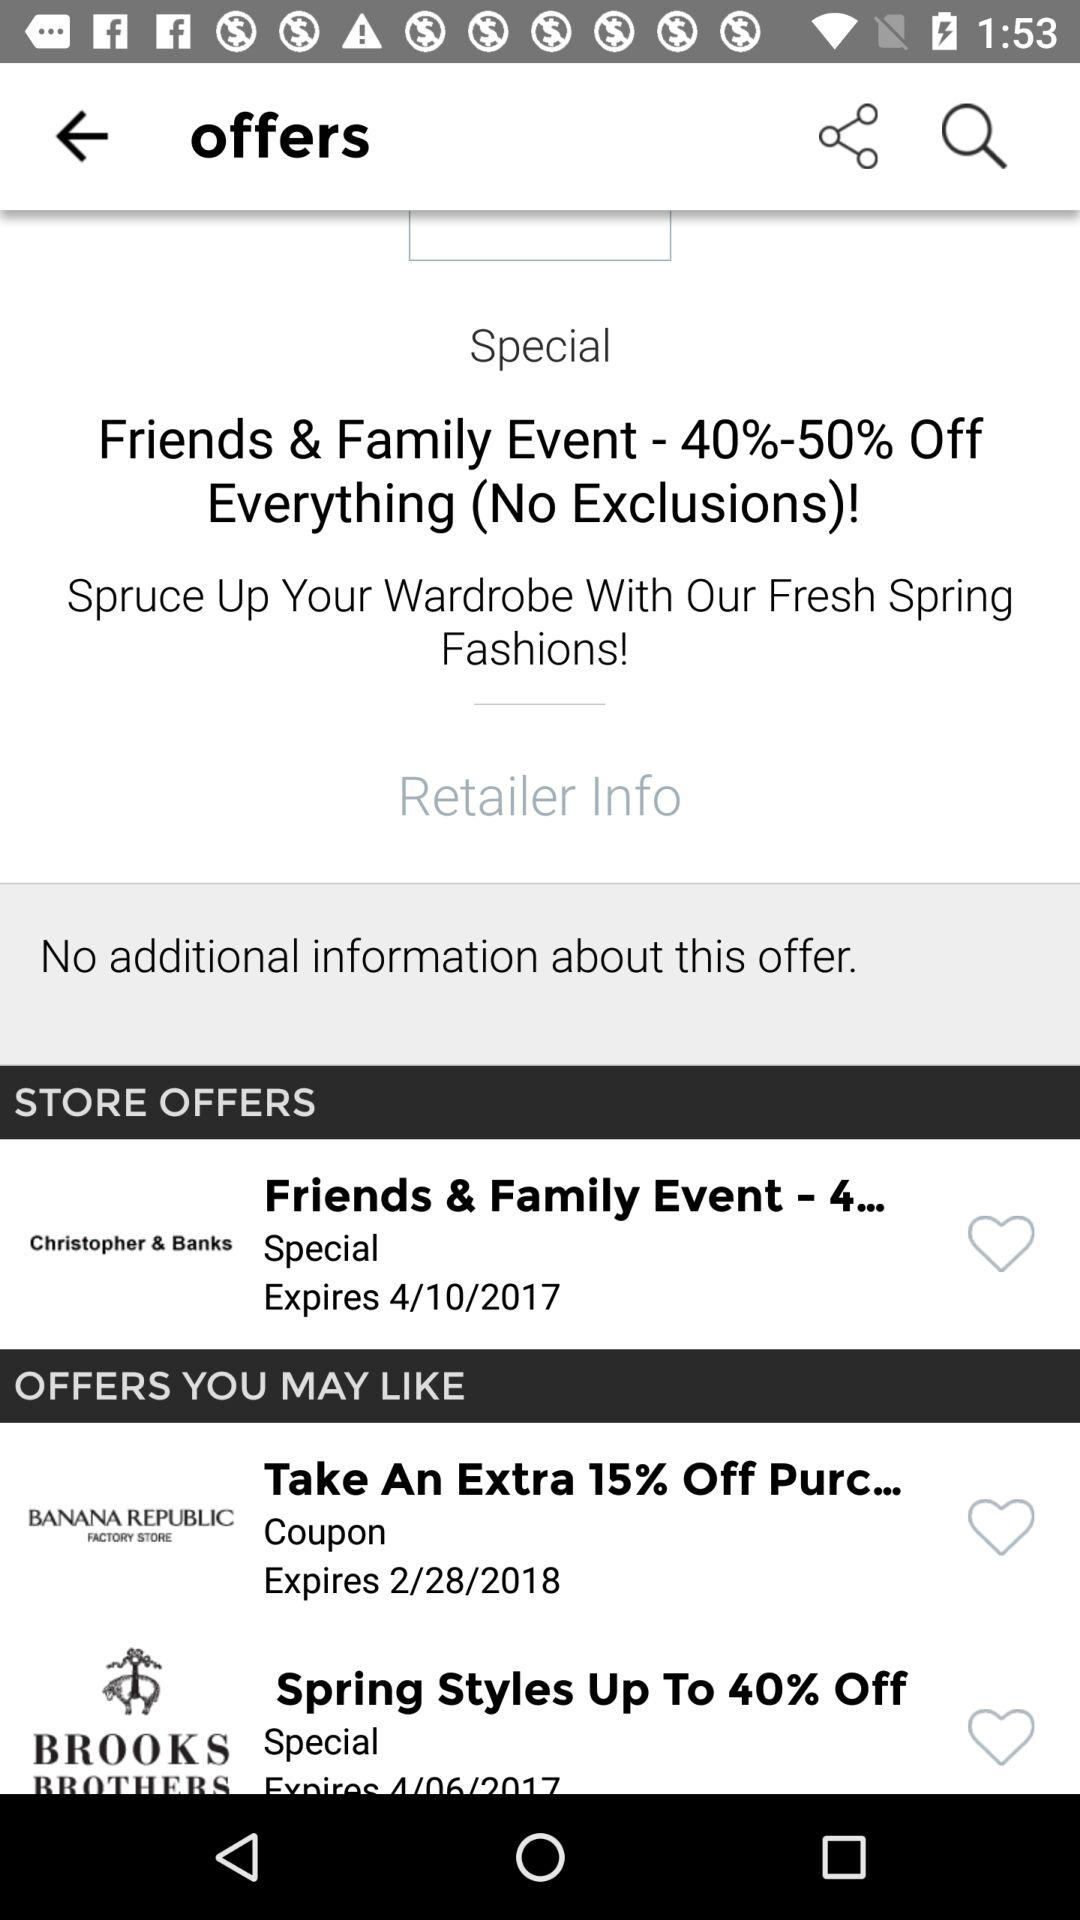Define the expire date of spring style?
When the provided information is insufficient, respond with <no answer>. <no answer> 